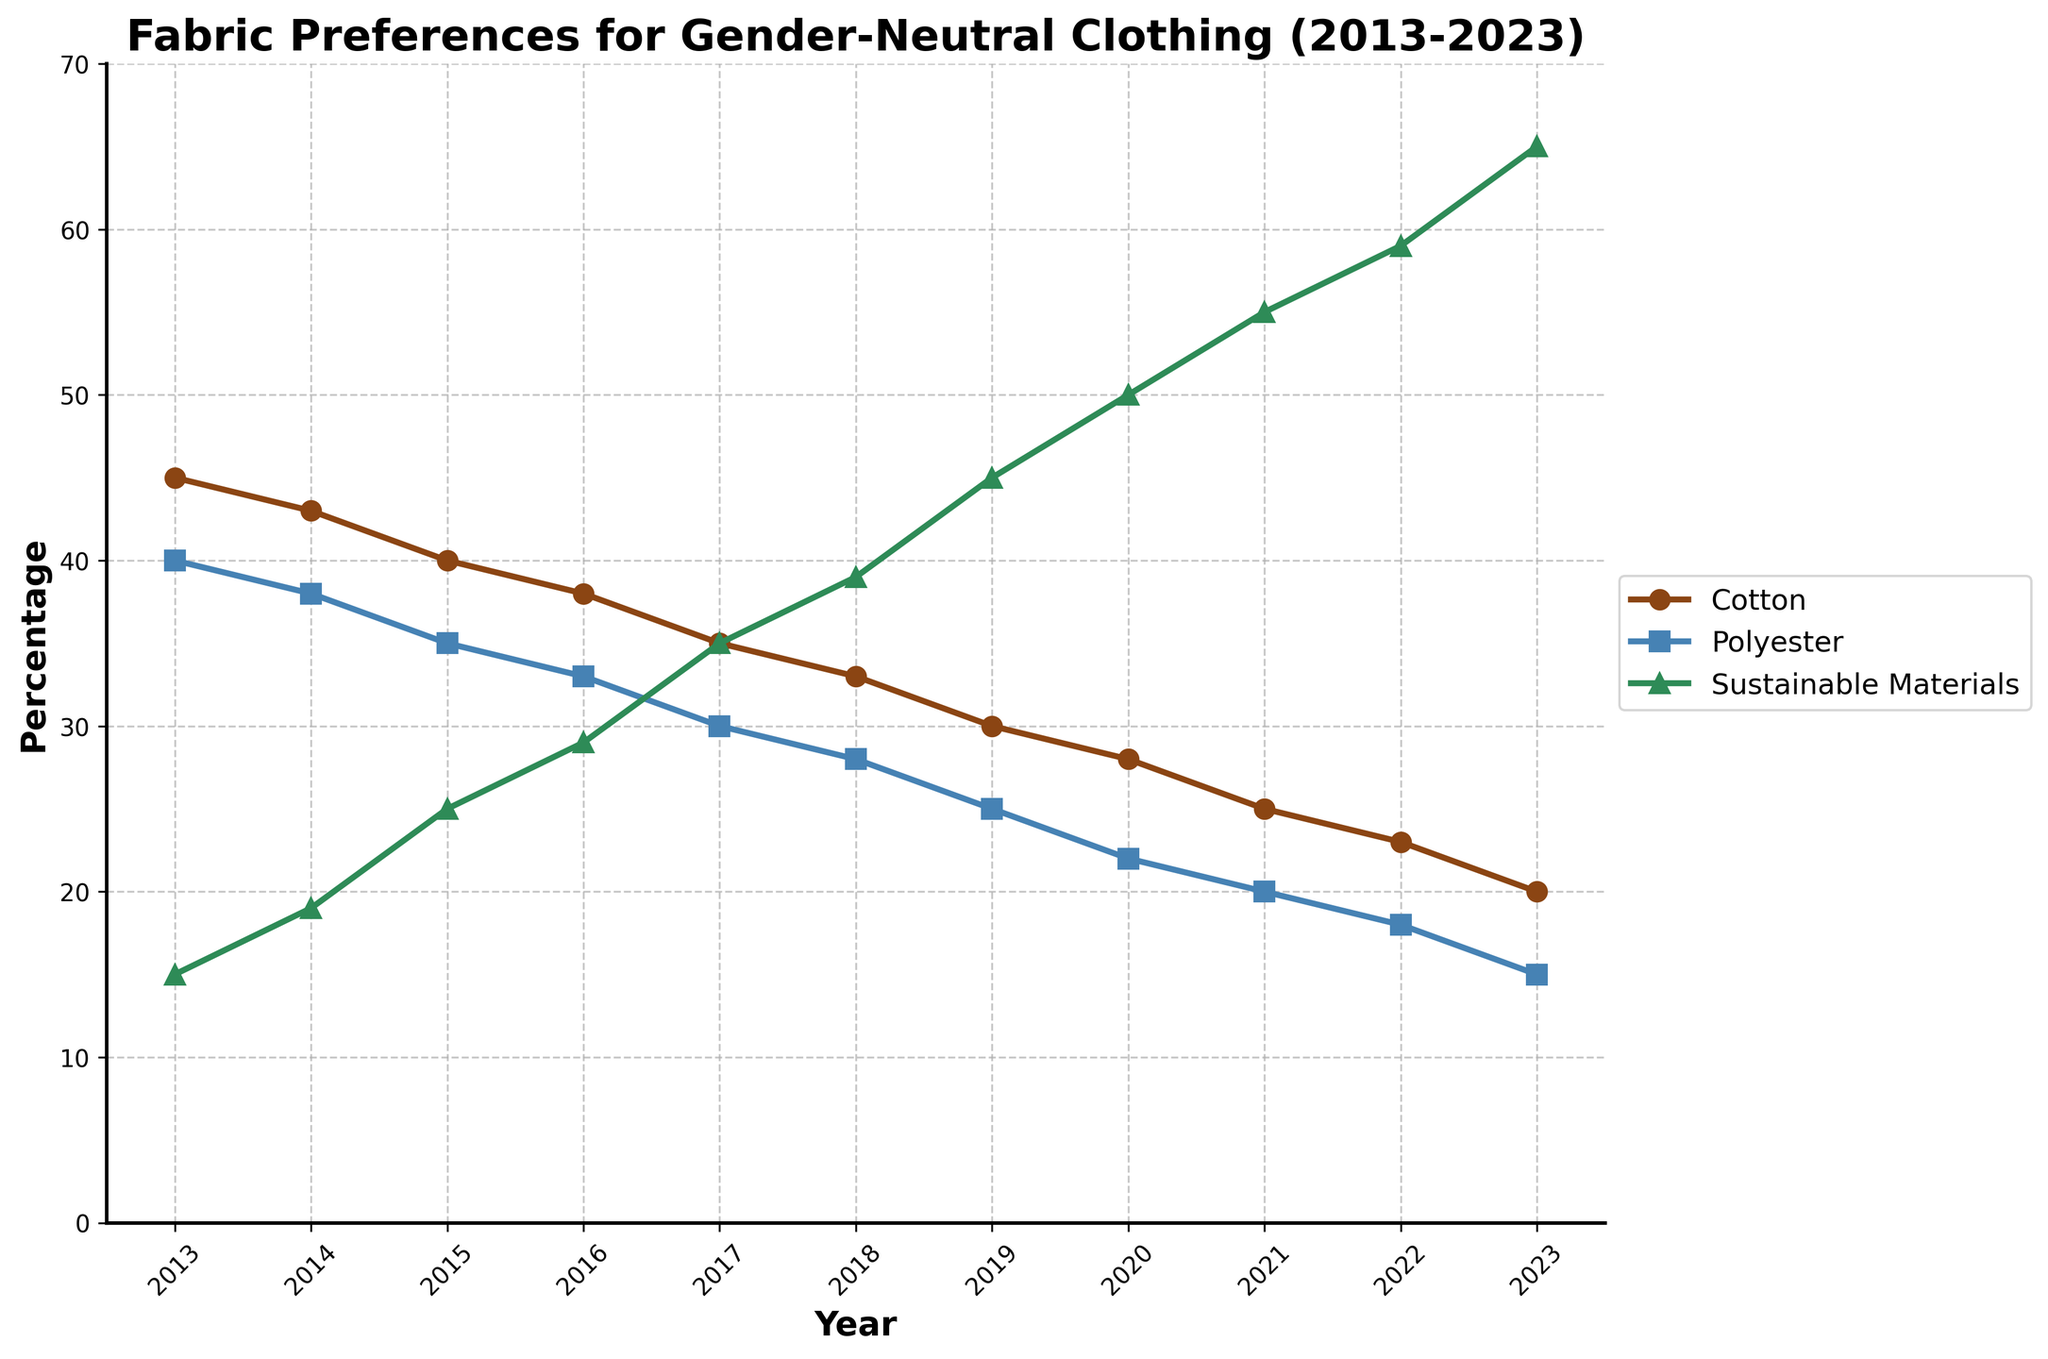What's the trend in the percentage of cotton usage over the decade? To determine the trend, we look at the line for cotton (depicted in brown). It starts high at 45% in 2013 and declines steadily to 20% by 2023, indicating a decrease in cotton usage over the decade.
Answer: Decreasing trend What year did sustainable materials surpass 50% in preference? To find this, detect the point where the green line for sustainable materials crosses the 50% mark. This occurs between 2019 and 2020. Checking the data, in 2020, the percentage of sustainable materials is exactly 50%.
Answer: 2020 Which fabric saw the largest increase in preference over the decade? For this, examine the slopes of the lines. Cotton and polyester lines fall while sustainable materials rise steeply from 15% in 2013 to 65% in 2023, indicating the largest increase.
Answer: Sustainable materials How much has polyester usage decreased from 2013 to 2023? Identify the percentages for polyester in 2013 (40%) and 2023 (15%). The difference is 40% - 15% which is 25%.
Answer: 25% Which year saw the equal preference for cotton and polyester? Look for the intersection of the brown and blue lines representing cotton and polyester. This happens around 2017, where both lines are at 30%.
Answer: 2017 In 2022, what is the combined preference percentage for cotton and polyester? Identify the percentages in 2022: 23% for cotton and 18% for polyester. Add them up: 23% + 18% = 41%.
Answer: 41% Between 2015 and 2020, how much did the preference for sustainable materials increase? Check data points for sustainable materials in 2015 (25%) and 2020 (50%). The increase is 50% - 25% = 25%.
Answer: 25% Which fabric had the smallest change in percentage from 2014 to 2015? Examine the changes between 2014 and 2015: Cotton drops from 43% to 40% (3% decrease), polyester from 38% to 35% (3% decrease), and sustainable materials increase from 19% to 25% (6% increase). Both cotton and polyester had the smallest change of 3%.
Answer: Cotton and Polyester If you were to describe the visual marker for sustainable materials, what would it be? Each line has different markers: green line for sustainable materials is represented by triangles (^) on the plot.
Answer: Triangles 